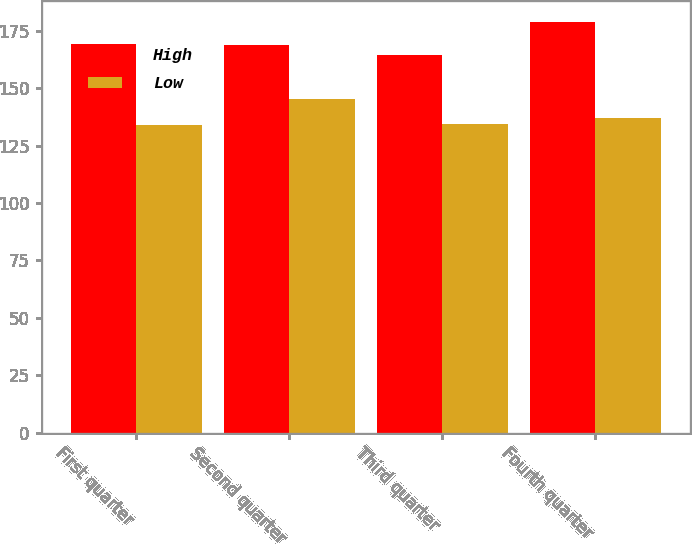<chart> <loc_0><loc_0><loc_500><loc_500><stacked_bar_chart><ecel><fcel>First quarter<fcel>Second quarter<fcel>Third quarter<fcel>Fourth quarter<nl><fcel>High<fcel>169.29<fcel>168.87<fcel>164.29<fcel>178.86<nl><fcel>Low<fcel>133.82<fcel>145.13<fcel>134.25<fcel>137.1<nl></chart> 